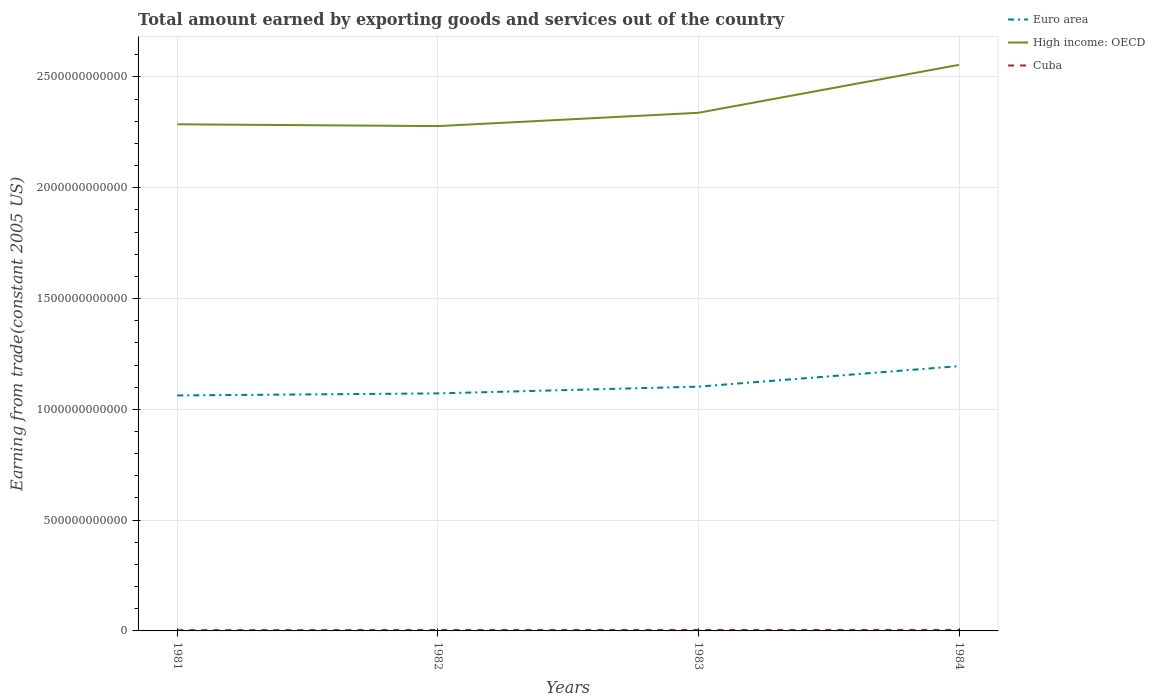How many different coloured lines are there?
Offer a terse response. 3. Is the number of lines equal to the number of legend labels?
Your response must be concise. Yes. Across all years, what is the maximum total amount earned by exporting goods and services in Euro area?
Offer a terse response. 1.06e+12. What is the total total amount earned by exporting goods and services in Euro area in the graph?
Your answer should be very brief. -1.23e+11. What is the difference between the highest and the second highest total amount earned by exporting goods and services in High income: OECD?
Give a very brief answer. 2.76e+11. Is the total amount earned by exporting goods and services in High income: OECD strictly greater than the total amount earned by exporting goods and services in Cuba over the years?
Your answer should be compact. No. How many lines are there?
Offer a terse response. 3. How many years are there in the graph?
Your response must be concise. 4. What is the difference between two consecutive major ticks on the Y-axis?
Provide a short and direct response. 5.00e+11. Does the graph contain any zero values?
Your answer should be very brief. No. Where does the legend appear in the graph?
Keep it short and to the point. Top right. How many legend labels are there?
Ensure brevity in your answer.  3. How are the legend labels stacked?
Your response must be concise. Vertical. What is the title of the graph?
Your answer should be very brief. Total amount earned by exporting goods and services out of the country. Does "Grenada" appear as one of the legend labels in the graph?
Ensure brevity in your answer.  No. What is the label or title of the Y-axis?
Offer a very short reply. Earning from trade(constant 2005 US). What is the Earning from trade(constant 2005 US) of Euro area in 1981?
Your answer should be compact. 1.06e+12. What is the Earning from trade(constant 2005 US) in High income: OECD in 1981?
Provide a short and direct response. 2.29e+12. What is the Earning from trade(constant 2005 US) of Cuba in 1981?
Your response must be concise. 3.61e+09. What is the Earning from trade(constant 2005 US) of Euro area in 1982?
Offer a terse response. 1.07e+12. What is the Earning from trade(constant 2005 US) of High income: OECD in 1982?
Provide a succinct answer. 2.28e+12. What is the Earning from trade(constant 2005 US) in Cuba in 1982?
Provide a short and direct response. 3.94e+09. What is the Earning from trade(constant 2005 US) of Euro area in 1983?
Keep it short and to the point. 1.10e+12. What is the Earning from trade(constant 2005 US) of High income: OECD in 1983?
Ensure brevity in your answer.  2.34e+12. What is the Earning from trade(constant 2005 US) of Cuba in 1983?
Your answer should be compact. 4.14e+09. What is the Earning from trade(constant 2005 US) of Euro area in 1984?
Make the answer very short. 1.20e+12. What is the Earning from trade(constant 2005 US) in High income: OECD in 1984?
Make the answer very short. 2.55e+12. What is the Earning from trade(constant 2005 US) of Cuba in 1984?
Offer a very short reply. 4.42e+09. Across all years, what is the maximum Earning from trade(constant 2005 US) in Euro area?
Ensure brevity in your answer.  1.20e+12. Across all years, what is the maximum Earning from trade(constant 2005 US) of High income: OECD?
Offer a terse response. 2.55e+12. Across all years, what is the maximum Earning from trade(constant 2005 US) in Cuba?
Offer a very short reply. 4.42e+09. Across all years, what is the minimum Earning from trade(constant 2005 US) in Euro area?
Ensure brevity in your answer.  1.06e+12. Across all years, what is the minimum Earning from trade(constant 2005 US) of High income: OECD?
Give a very brief answer. 2.28e+12. Across all years, what is the minimum Earning from trade(constant 2005 US) in Cuba?
Provide a succinct answer. 3.61e+09. What is the total Earning from trade(constant 2005 US) of Euro area in the graph?
Ensure brevity in your answer.  4.43e+12. What is the total Earning from trade(constant 2005 US) in High income: OECD in the graph?
Give a very brief answer. 9.46e+12. What is the total Earning from trade(constant 2005 US) of Cuba in the graph?
Ensure brevity in your answer.  1.61e+1. What is the difference between the Earning from trade(constant 2005 US) in Euro area in 1981 and that in 1982?
Your answer should be very brief. -9.20e+09. What is the difference between the Earning from trade(constant 2005 US) in High income: OECD in 1981 and that in 1982?
Provide a succinct answer. 8.14e+09. What is the difference between the Earning from trade(constant 2005 US) in Cuba in 1981 and that in 1982?
Give a very brief answer. -3.34e+08. What is the difference between the Earning from trade(constant 2005 US) in Euro area in 1981 and that in 1983?
Offer a terse response. -3.98e+1. What is the difference between the Earning from trade(constant 2005 US) of High income: OECD in 1981 and that in 1983?
Make the answer very short. -5.20e+1. What is the difference between the Earning from trade(constant 2005 US) of Cuba in 1981 and that in 1983?
Provide a short and direct response. -5.36e+08. What is the difference between the Earning from trade(constant 2005 US) in Euro area in 1981 and that in 1984?
Your response must be concise. -1.32e+11. What is the difference between the Earning from trade(constant 2005 US) in High income: OECD in 1981 and that in 1984?
Ensure brevity in your answer.  -2.68e+11. What is the difference between the Earning from trade(constant 2005 US) of Cuba in 1981 and that in 1984?
Your answer should be compact. -8.13e+08. What is the difference between the Earning from trade(constant 2005 US) of Euro area in 1982 and that in 1983?
Your response must be concise. -3.06e+1. What is the difference between the Earning from trade(constant 2005 US) in High income: OECD in 1982 and that in 1983?
Give a very brief answer. -6.01e+1. What is the difference between the Earning from trade(constant 2005 US) in Cuba in 1982 and that in 1983?
Provide a succinct answer. -2.02e+08. What is the difference between the Earning from trade(constant 2005 US) in Euro area in 1982 and that in 1984?
Keep it short and to the point. -1.23e+11. What is the difference between the Earning from trade(constant 2005 US) in High income: OECD in 1982 and that in 1984?
Ensure brevity in your answer.  -2.76e+11. What is the difference between the Earning from trade(constant 2005 US) in Cuba in 1982 and that in 1984?
Your response must be concise. -4.79e+08. What is the difference between the Earning from trade(constant 2005 US) in Euro area in 1983 and that in 1984?
Offer a very short reply. -9.26e+1. What is the difference between the Earning from trade(constant 2005 US) in High income: OECD in 1983 and that in 1984?
Your answer should be very brief. -2.16e+11. What is the difference between the Earning from trade(constant 2005 US) of Cuba in 1983 and that in 1984?
Make the answer very short. -2.77e+08. What is the difference between the Earning from trade(constant 2005 US) in Euro area in 1981 and the Earning from trade(constant 2005 US) in High income: OECD in 1982?
Your answer should be compact. -1.22e+12. What is the difference between the Earning from trade(constant 2005 US) in Euro area in 1981 and the Earning from trade(constant 2005 US) in Cuba in 1982?
Ensure brevity in your answer.  1.06e+12. What is the difference between the Earning from trade(constant 2005 US) of High income: OECD in 1981 and the Earning from trade(constant 2005 US) of Cuba in 1982?
Provide a short and direct response. 2.28e+12. What is the difference between the Earning from trade(constant 2005 US) in Euro area in 1981 and the Earning from trade(constant 2005 US) in High income: OECD in 1983?
Your answer should be very brief. -1.28e+12. What is the difference between the Earning from trade(constant 2005 US) in Euro area in 1981 and the Earning from trade(constant 2005 US) in Cuba in 1983?
Offer a terse response. 1.06e+12. What is the difference between the Earning from trade(constant 2005 US) of High income: OECD in 1981 and the Earning from trade(constant 2005 US) of Cuba in 1983?
Your answer should be compact. 2.28e+12. What is the difference between the Earning from trade(constant 2005 US) in Euro area in 1981 and the Earning from trade(constant 2005 US) in High income: OECD in 1984?
Your answer should be compact. -1.49e+12. What is the difference between the Earning from trade(constant 2005 US) of Euro area in 1981 and the Earning from trade(constant 2005 US) of Cuba in 1984?
Your answer should be compact. 1.06e+12. What is the difference between the Earning from trade(constant 2005 US) in High income: OECD in 1981 and the Earning from trade(constant 2005 US) in Cuba in 1984?
Make the answer very short. 2.28e+12. What is the difference between the Earning from trade(constant 2005 US) in Euro area in 1982 and the Earning from trade(constant 2005 US) in High income: OECD in 1983?
Give a very brief answer. -1.27e+12. What is the difference between the Earning from trade(constant 2005 US) in Euro area in 1982 and the Earning from trade(constant 2005 US) in Cuba in 1983?
Make the answer very short. 1.07e+12. What is the difference between the Earning from trade(constant 2005 US) of High income: OECD in 1982 and the Earning from trade(constant 2005 US) of Cuba in 1983?
Your answer should be very brief. 2.27e+12. What is the difference between the Earning from trade(constant 2005 US) in Euro area in 1982 and the Earning from trade(constant 2005 US) in High income: OECD in 1984?
Your response must be concise. -1.48e+12. What is the difference between the Earning from trade(constant 2005 US) of Euro area in 1982 and the Earning from trade(constant 2005 US) of Cuba in 1984?
Make the answer very short. 1.07e+12. What is the difference between the Earning from trade(constant 2005 US) of High income: OECD in 1982 and the Earning from trade(constant 2005 US) of Cuba in 1984?
Make the answer very short. 2.27e+12. What is the difference between the Earning from trade(constant 2005 US) in Euro area in 1983 and the Earning from trade(constant 2005 US) in High income: OECD in 1984?
Give a very brief answer. -1.45e+12. What is the difference between the Earning from trade(constant 2005 US) of Euro area in 1983 and the Earning from trade(constant 2005 US) of Cuba in 1984?
Give a very brief answer. 1.10e+12. What is the difference between the Earning from trade(constant 2005 US) in High income: OECD in 1983 and the Earning from trade(constant 2005 US) in Cuba in 1984?
Offer a very short reply. 2.33e+12. What is the average Earning from trade(constant 2005 US) of Euro area per year?
Make the answer very short. 1.11e+12. What is the average Earning from trade(constant 2005 US) of High income: OECD per year?
Offer a very short reply. 2.36e+12. What is the average Earning from trade(constant 2005 US) of Cuba per year?
Your answer should be very brief. 4.03e+09. In the year 1981, what is the difference between the Earning from trade(constant 2005 US) of Euro area and Earning from trade(constant 2005 US) of High income: OECD?
Your response must be concise. -1.22e+12. In the year 1981, what is the difference between the Earning from trade(constant 2005 US) in Euro area and Earning from trade(constant 2005 US) in Cuba?
Offer a very short reply. 1.06e+12. In the year 1981, what is the difference between the Earning from trade(constant 2005 US) of High income: OECD and Earning from trade(constant 2005 US) of Cuba?
Provide a short and direct response. 2.28e+12. In the year 1982, what is the difference between the Earning from trade(constant 2005 US) in Euro area and Earning from trade(constant 2005 US) in High income: OECD?
Your answer should be compact. -1.21e+12. In the year 1982, what is the difference between the Earning from trade(constant 2005 US) in Euro area and Earning from trade(constant 2005 US) in Cuba?
Keep it short and to the point. 1.07e+12. In the year 1982, what is the difference between the Earning from trade(constant 2005 US) of High income: OECD and Earning from trade(constant 2005 US) of Cuba?
Your response must be concise. 2.27e+12. In the year 1983, what is the difference between the Earning from trade(constant 2005 US) of Euro area and Earning from trade(constant 2005 US) of High income: OECD?
Give a very brief answer. -1.24e+12. In the year 1983, what is the difference between the Earning from trade(constant 2005 US) of Euro area and Earning from trade(constant 2005 US) of Cuba?
Your answer should be compact. 1.10e+12. In the year 1983, what is the difference between the Earning from trade(constant 2005 US) in High income: OECD and Earning from trade(constant 2005 US) in Cuba?
Provide a succinct answer. 2.33e+12. In the year 1984, what is the difference between the Earning from trade(constant 2005 US) of Euro area and Earning from trade(constant 2005 US) of High income: OECD?
Make the answer very short. -1.36e+12. In the year 1984, what is the difference between the Earning from trade(constant 2005 US) in Euro area and Earning from trade(constant 2005 US) in Cuba?
Make the answer very short. 1.19e+12. In the year 1984, what is the difference between the Earning from trade(constant 2005 US) of High income: OECD and Earning from trade(constant 2005 US) of Cuba?
Provide a succinct answer. 2.55e+12. What is the ratio of the Earning from trade(constant 2005 US) in Cuba in 1981 to that in 1982?
Make the answer very short. 0.92. What is the ratio of the Earning from trade(constant 2005 US) of Euro area in 1981 to that in 1983?
Ensure brevity in your answer.  0.96. What is the ratio of the Earning from trade(constant 2005 US) in High income: OECD in 1981 to that in 1983?
Your answer should be very brief. 0.98. What is the ratio of the Earning from trade(constant 2005 US) of Cuba in 1981 to that in 1983?
Offer a terse response. 0.87. What is the ratio of the Earning from trade(constant 2005 US) in Euro area in 1981 to that in 1984?
Keep it short and to the point. 0.89. What is the ratio of the Earning from trade(constant 2005 US) of High income: OECD in 1981 to that in 1984?
Offer a terse response. 0.9. What is the ratio of the Earning from trade(constant 2005 US) of Cuba in 1981 to that in 1984?
Ensure brevity in your answer.  0.82. What is the ratio of the Earning from trade(constant 2005 US) of Euro area in 1982 to that in 1983?
Provide a succinct answer. 0.97. What is the ratio of the Earning from trade(constant 2005 US) of High income: OECD in 1982 to that in 1983?
Offer a very short reply. 0.97. What is the ratio of the Earning from trade(constant 2005 US) of Cuba in 1982 to that in 1983?
Your response must be concise. 0.95. What is the ratio of the Earning from trade(constant 2005 US) in Euro area in 1982 to that in 1984?
Your answer should be compact. 0.9. What is the ratio of the Earning from trade(constant 2005 US) in High income: OECD in 1982 to that in 1984?
Offer a very short reply. 0.89. What is the ratio of the Earning from trade(constant 2005 US) of Cuba in 1982 to that in 1984?
Ensure brevity in your answer.  0.89. What is the ratio of the Earning from trade(constant 2005 US) in Euro area in 1983 to that in 1984?
Give a very brief answer. 0.92. What is the ratio of the Earning from trade(constant 2005 US) of High income: OECD in 1983 to that in 1984?
Your response must be concise. 0.92. What is the ratio of the Earning from trade(constant 2005 US) of Cuba in 1983 to that in 1984?
Make the answer very short. 0.94. What is the difference between the highest and the second highest Earning from trade(constant 2005 US) in Euro area?
Keep it short and to the point. 9.26e+1. What is the difference between the highest and the second highest Earning from trade(constant 2005 US) in High income: OECD?
Offer a very short reply. 2.16e+11. What is the difference between the highest and the second highest Earning from trade(constant 2005 US) in Cuba?
Ensure brevity in your answer.  2.77e+08. What is the difference between the highest and the lowest Earning from trade(constant 2005 US) in Euro area?
Your answer should be compact. 1.32e+11. What is the difference between the highest and the lowest Earning from trade(constant 2005 US) of High income: OECD?
Keep it short and to the point. 2.76e+11. What is the difference between the highest and the lowest Earning from trade(constant 2005 US) in Cuba?
Offer a terse response. 8.13e+08. 